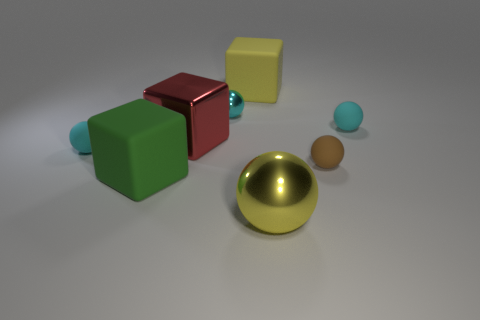The small metallic object has what color?
Keep it short and to the point. Cyan. What number of other things are the same size as the shiny cube?
Provide a succinct answer. 3. There is a big thing that is the same shape as the tiny cyan metal thing; what is its material?
Keep it short and to the point. Metal. There is a small sphere that is behind the small matte sphere that is behind the cyan ball left of the big red metallic object; what is its material?
Your answer should be compact. Metal. The green block that is made of the same material as the brown sphere is what size?
Your answer should be very brief. Large. Is there any other thing that is the same color as the tiny shiny sphere?
Your answer should be very brief. Yes. There is a sphere that is to the right of the tiny brown ball; does it have the same color as the big thing in front of the big green object?
Offer a very short reply. No. The rubber block that is to the right of the large metal block is what color?
Offer a terse response. Yellow. There is a cyan sphere that is in front of the shiny block; is its size the same as the large yellow matte object?
Offer a terse response. No. Is the number of red rubber spheres less than the number of yellow objects?
Make the answer very short. Yes. 